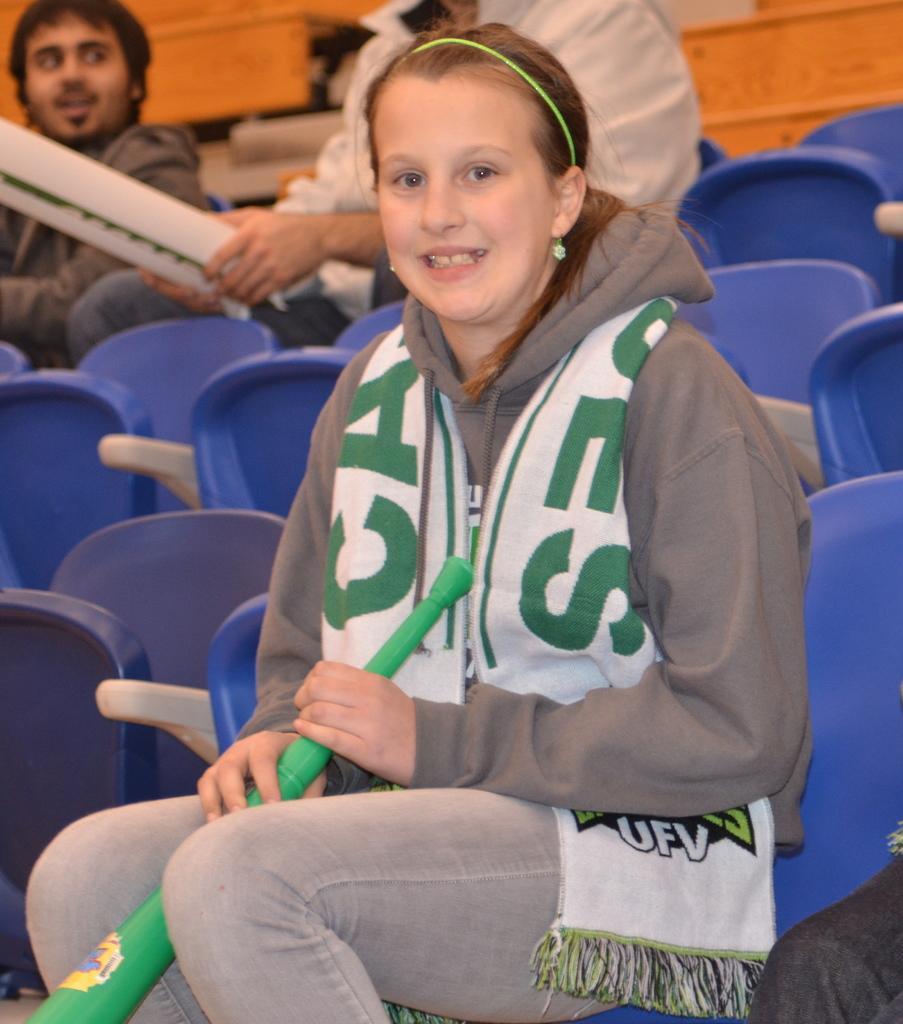Please provide a concise description of this image. In this image we can see a woman sitting and holding an object and posing for a photo and behind we can see some chairs and there are two persons sitting in the background and one among them is holding an object. 